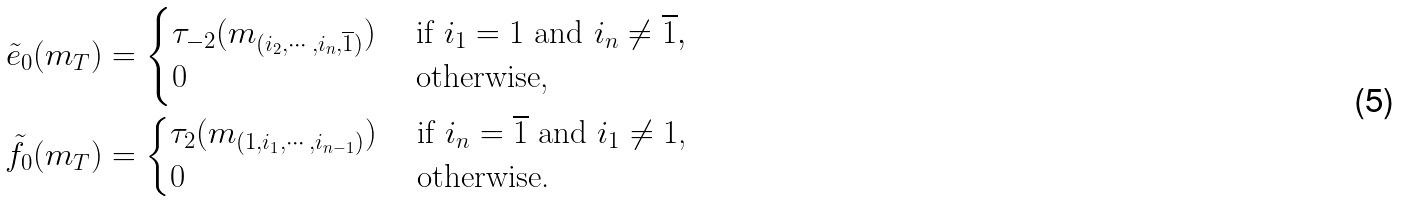Convert formula to latex. <formula><loc_0><loc_0><loc_500><loc_500>\tilde { e } _ { 0 } ( m _ { T } ) & = \begin{cases} \tau _ { - 2 } ( m _ { ( i _ { 2 } , \cdots , i _ { n } , \overline { 1 } ) } ) & \text { if $i_{1} = 1$ and $i_{n}\neq\overline{1}$} , \\ 0 & \text { otherwise,} \end{cases} \\ \tilde { f } _ { 0 } ( m _ { T } ) & = \begin{cases} \tau _ { 2 } ( m _ { ( 1 , i _ { 1 } , \cdots , i _ { n - 1 } ) } ) & \text { if $i_{n}=\overline{1}$ and $i_{1}\neq 1$,} \\ 0 & \text { otherwise.} \end{cases}</formula> 